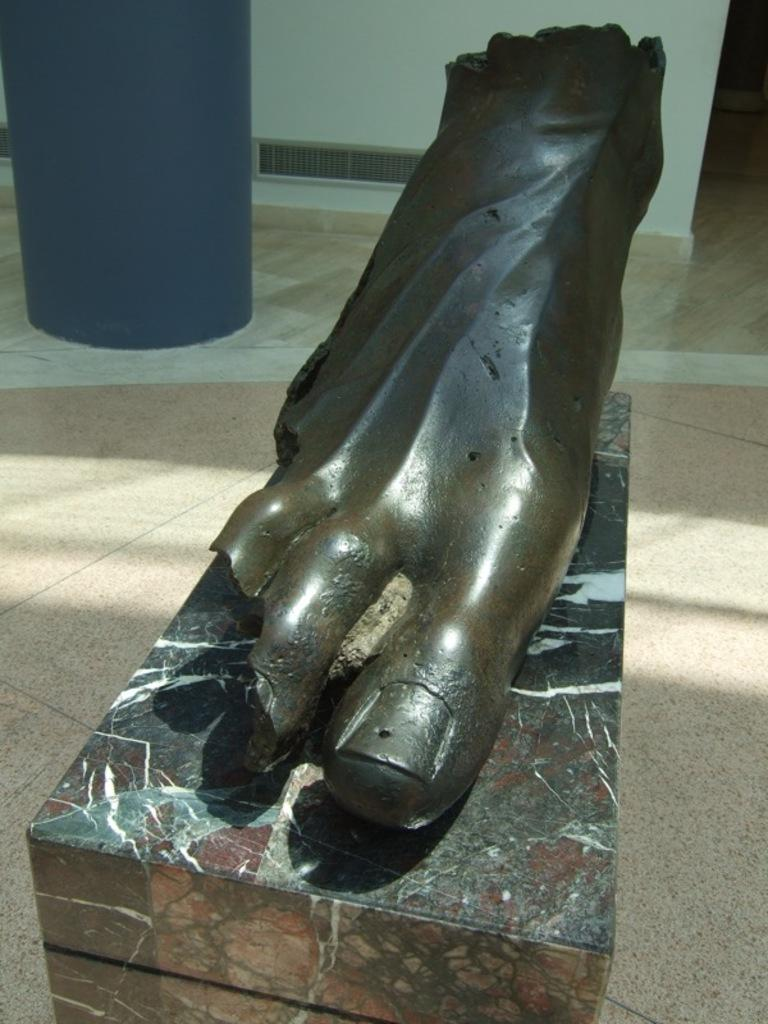What can be seen in the background of the image? There is a wall visible in the background of the image. What is the surface on which the object is placed? There is a floor visible in the image. What type of object is present in the image? There is an object in the image, specifically a sculpture of a foot on a pedestal. How many rabbits are sitting on the plate in the image? There are no rabbits or plates present in the image. What type of bird can be seen flying in the background of the image? There are no birds visible in the image. 